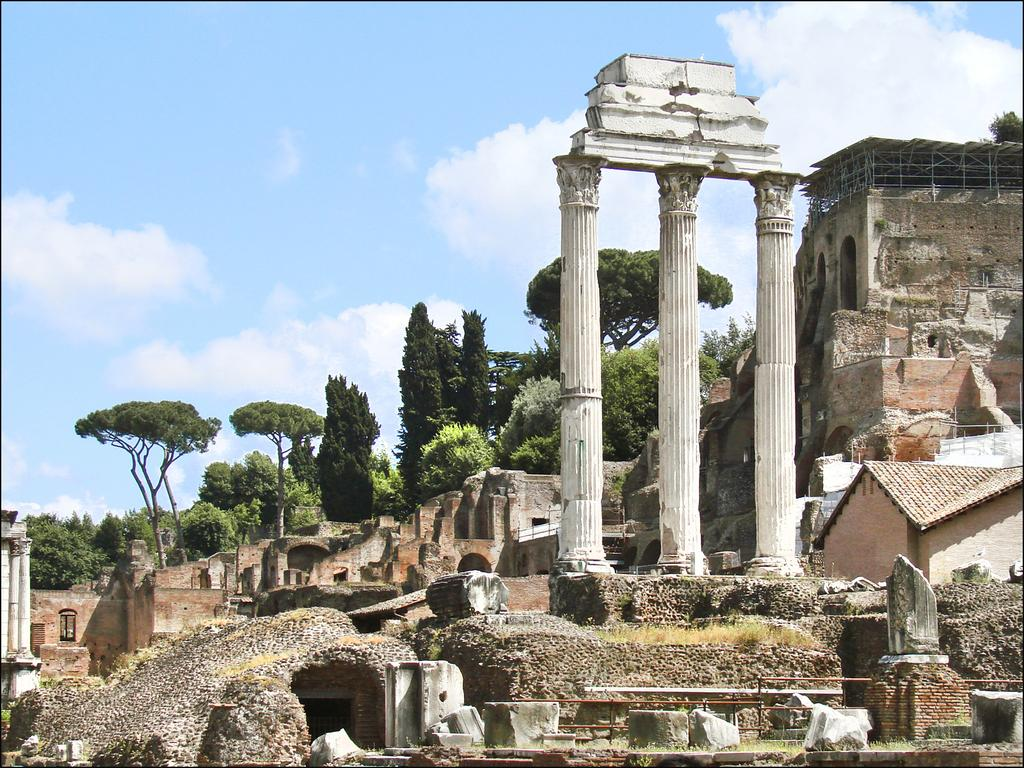What type of structures can be seen in the image? There are buildings in the image. What type of vegetation is visible in the image? There is grass visible in the image. What other natural elements can be seen in the image? There are trees in the image. What is visible in the background of the image? The sky is visible in the image. What can be observed in the sky? Clouds are present in the sky. What type of holiday is being celebrated in the image? There is no indication of a holiday being celebrated in the image. What is the mouth of the tree in the image? There are no mouths present in the image, as trees do not have mouths. 